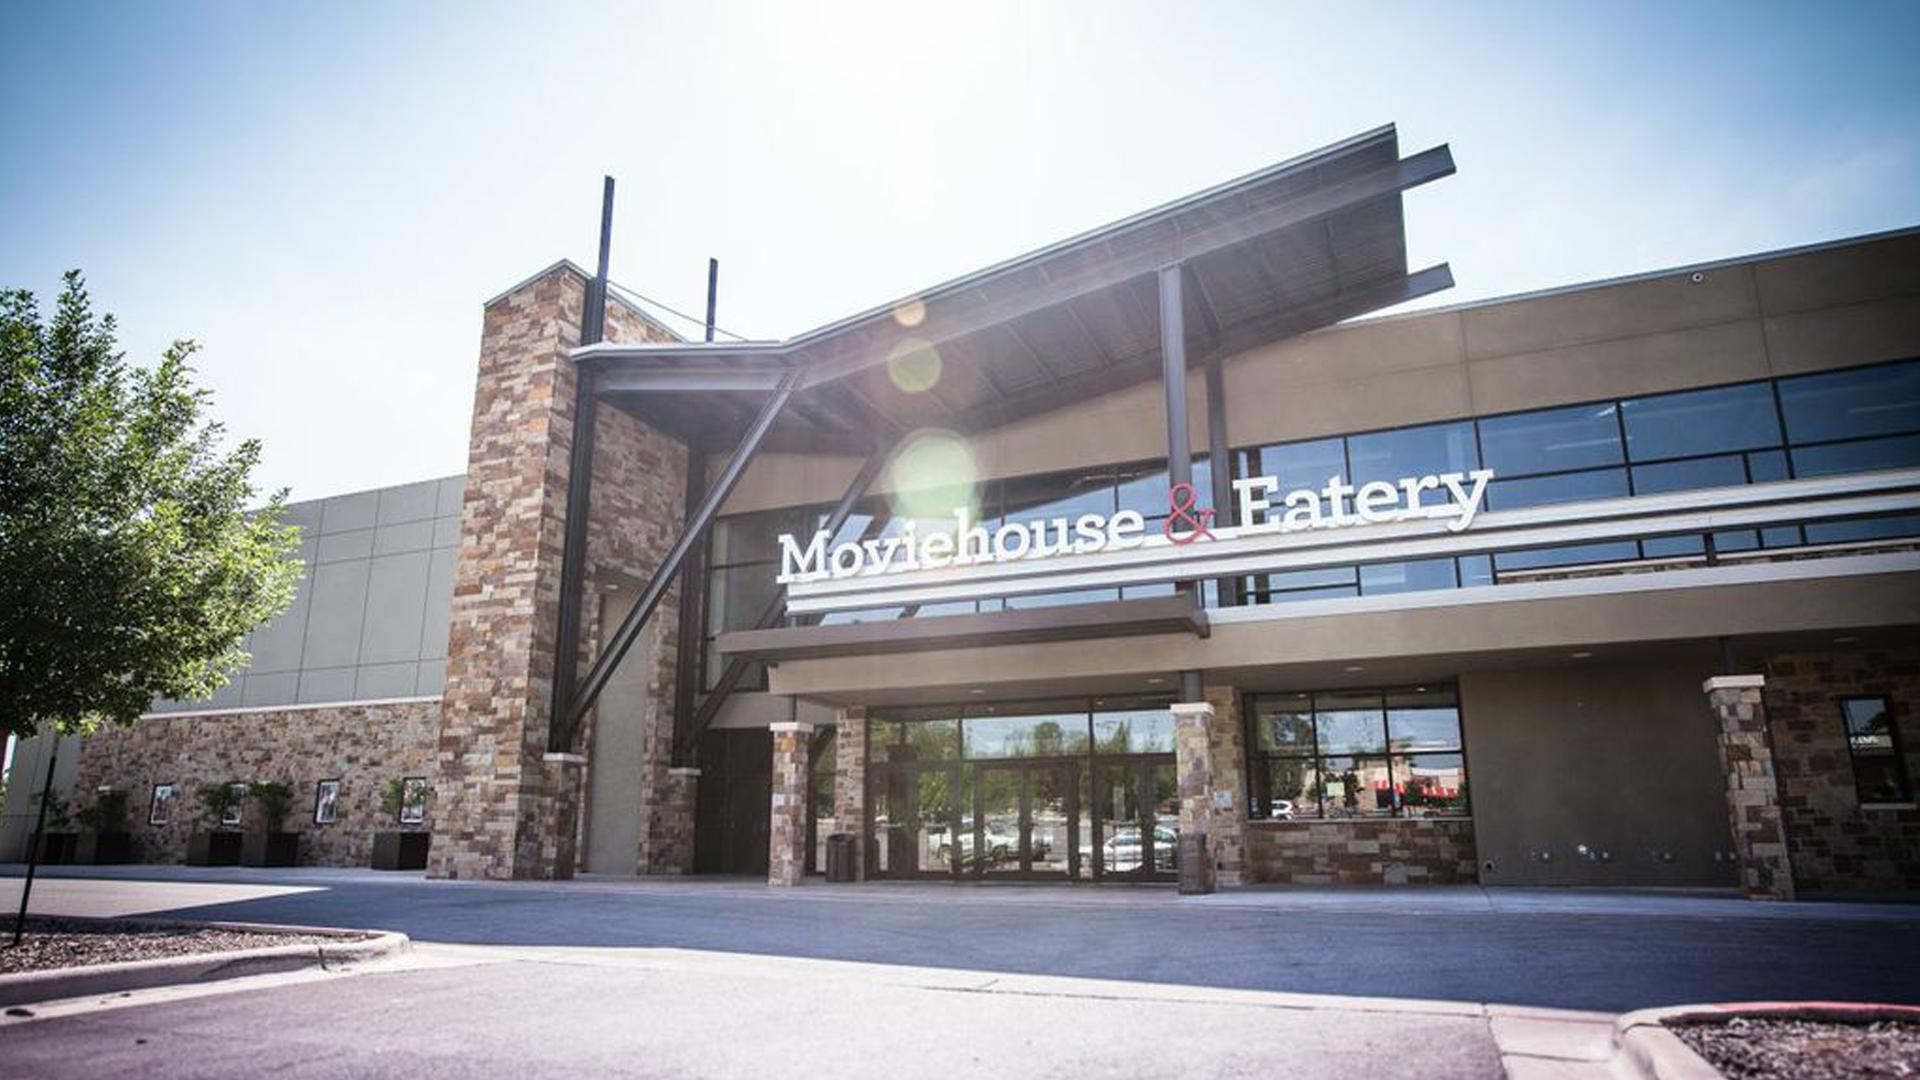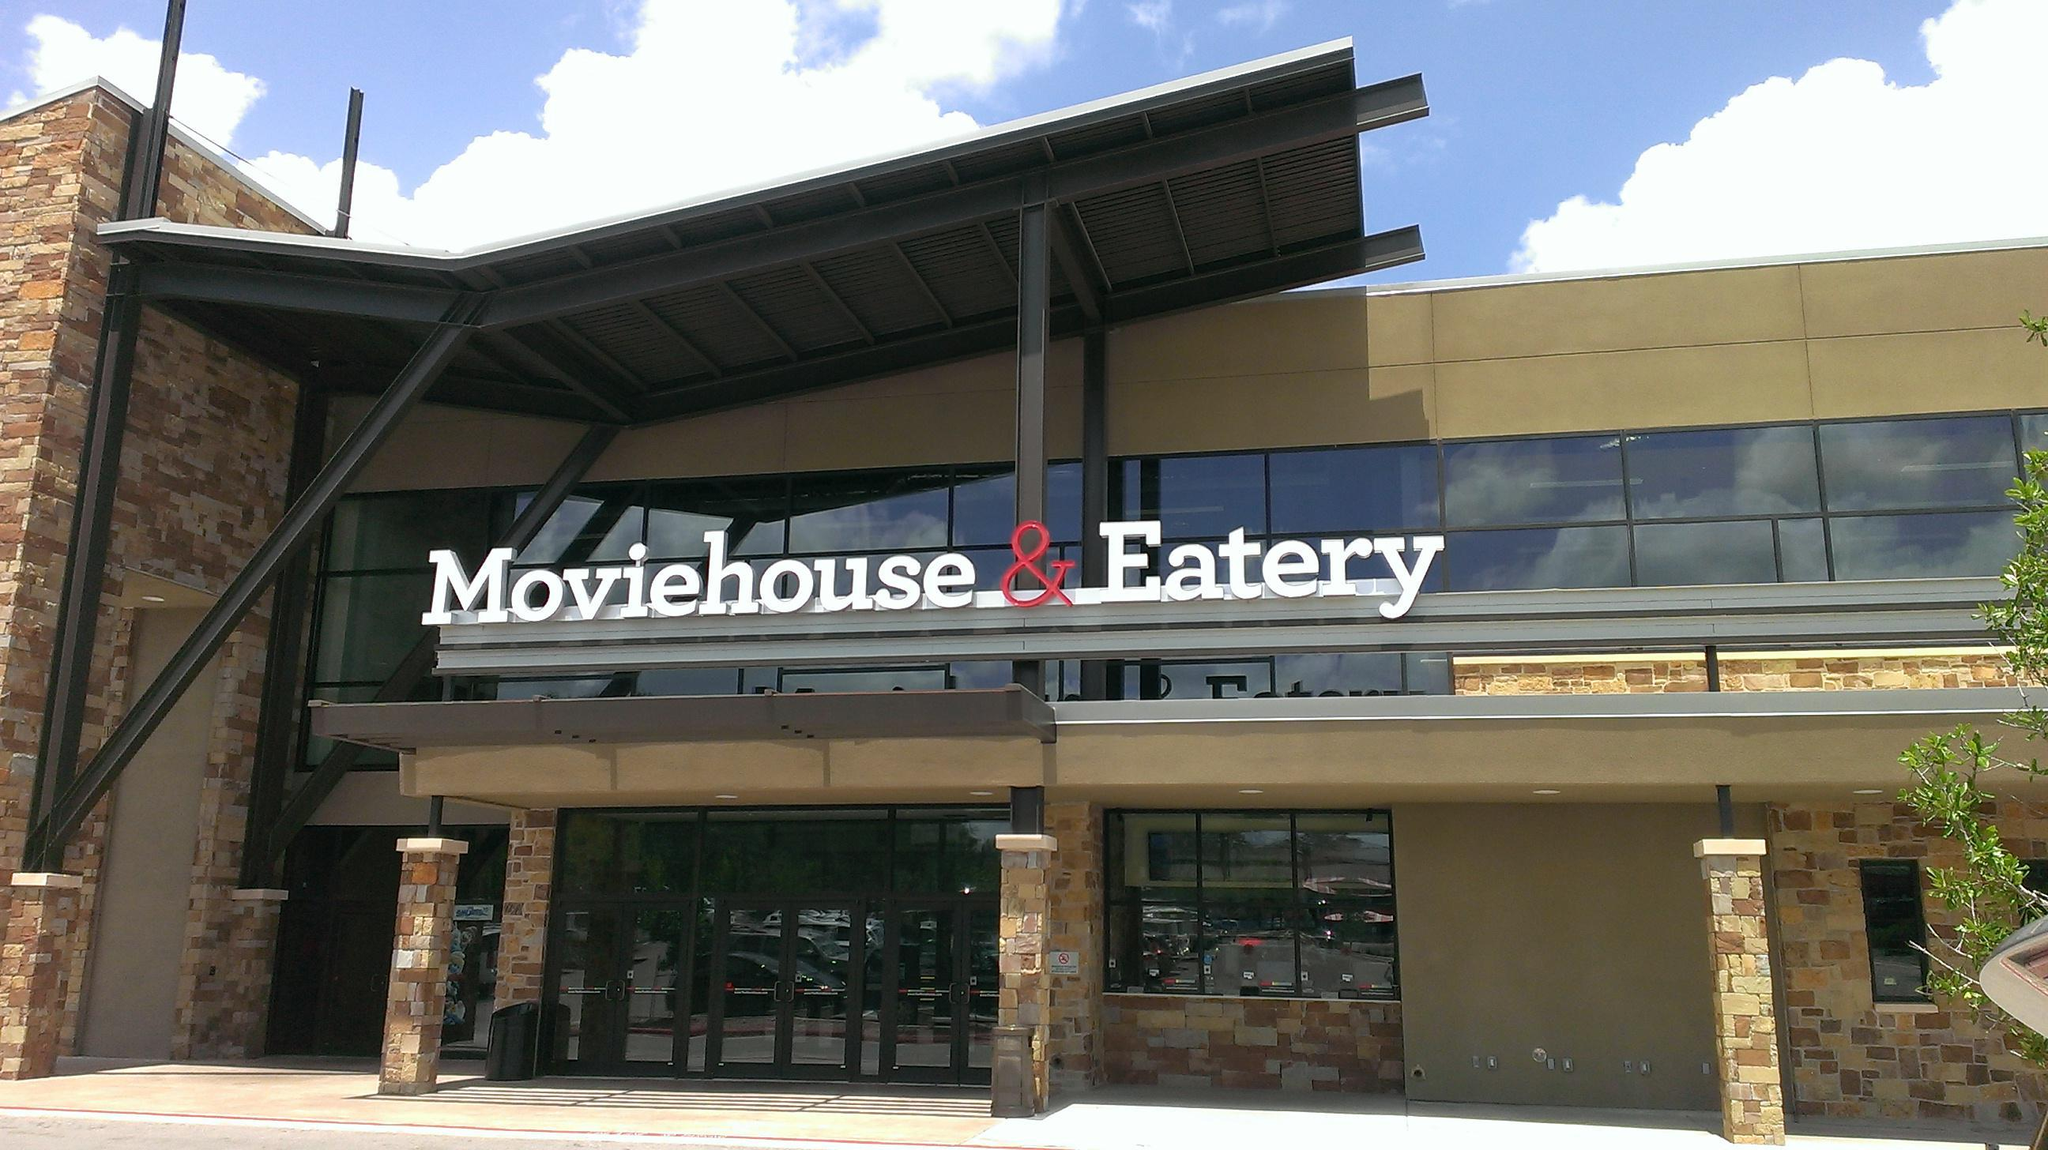The first image is the image on the left, the second image is the image on the right. Analyze the images presented: Is the assertion "Signage hangs above the entrance of the place in the image on the right." valid? Answer yes or no. Yes. The first image is the image on the left, the second image is the image on the right. For the images shown, is this caption "The right image shows an interior with backless stools leading to white chair-type stools at a bar with glowing yellow underlighting." true? Answer yes or no. No. 